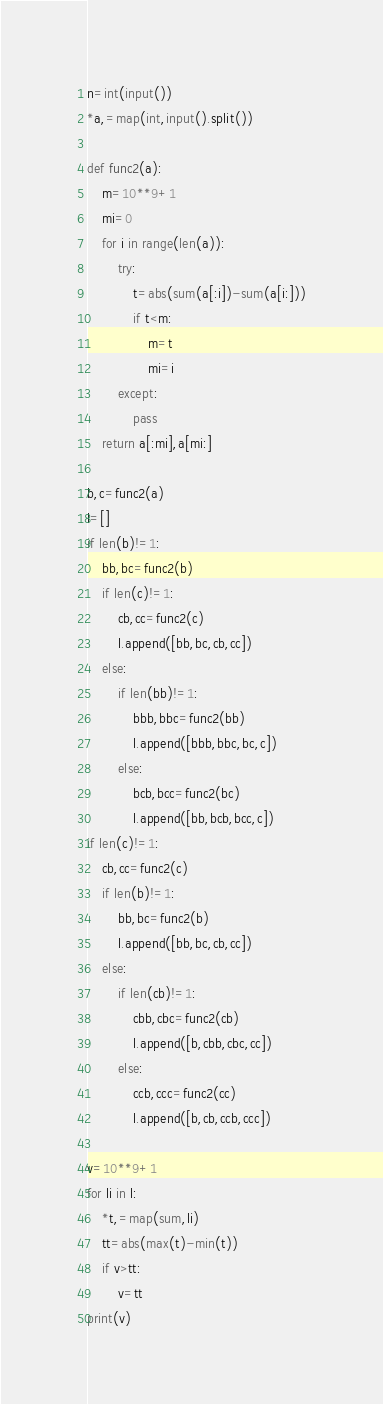<code> <loc_0><loc_0><loc_500><loc_500><_Python_>n=int(input())
*a,=map(int,input().split())

def func2(a):
    m=10**9+1
    mi=0
    for i in range(len(a)):
        try:
            t=abs(sum(a[:i])-sum(a[i:]))
            if t<m:
                m=t
                mi=i   
        except:
            pass
    return a[:mi],a[mi:]
  
b,c=func2(a)
l=[]
if len(b)!=1:
    bb,bc=func2(b)
    if len(c)!=1:
        cb,cc=func2(c)
        l.append([bb,bc,cb,cc])
    else:
        if len(bb)!=1:
            bbb,bbc=func2(bb)
            l.append([bbb,bbc,bc,c])
        else:
            bcb,bcc=func2(bc)
            l.append([bb,bcb,bcc,c])
if len(c)!=1:
    cb,cc=func2(c)
    if len(b)!=1:
        bb,bc=func2(b)
        l.append([bb,bc,cb,cc])
    else:
        if len(cb)!=1:
            cbb,cbc=func2(cb)
            l.append([b,cbb,cbc,cc])
        else:
            ccb,ccc=func2(cc)
            l.append([b,cb,ccb,ccc])
            
v=10**9+1
for li in l:
    *t,=map(sum,li)
    tt=abs(max(t)-min(t))
    if v>tt:
        v=tt
print(v)</code> 